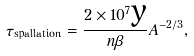Convert formula to latex. <formula><loc_0><loc_0><loc_500><loc_500>\tau _ { \text {spallation} } = \frac { 2 \times 1 0 ^ { 7 } \text {y} } { n \beta } A ^ { - 2 / 3 } ,</formula> 